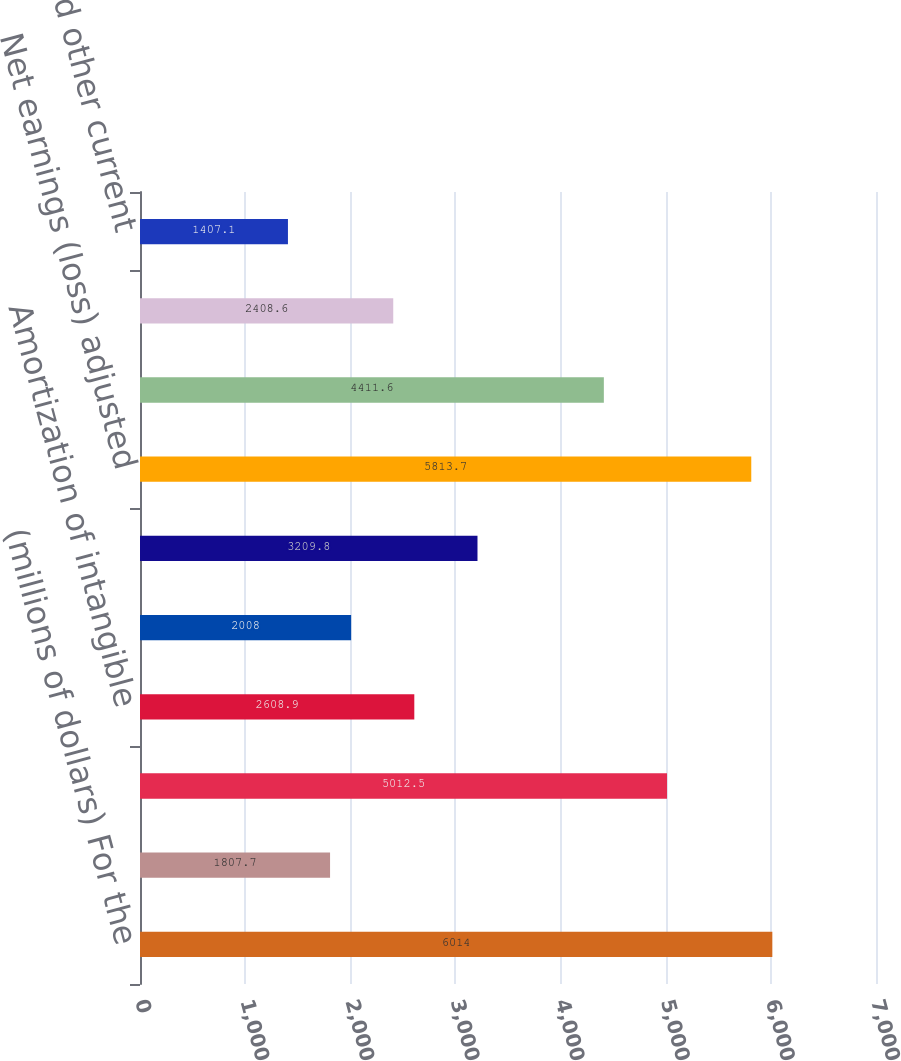Convert chart. <chart><loc_0><loc_0><loc_500><loc_500><bar_chart><fcel>(millions of dollars) For the<fcel>Net earnings (loss)<fcel>Depreciation and tooling<fcel>Amortization of intangible<fcel>Stock based compensation<fcel>Deferred income tax benefit<fcel>Net earnings (loss) adjusted<fcel>Receivables<fcel>Inventories<fcel>Prepayments and other current<nl><fcel>6014<fcel>1807.7<fcel>5012.5<fcel>2608.9<fcel>2008<fcel>3209.8<fcel>5813.7<fcel>4411.6<fcel>2408.6<fcel>1407.1<nl></chart> 